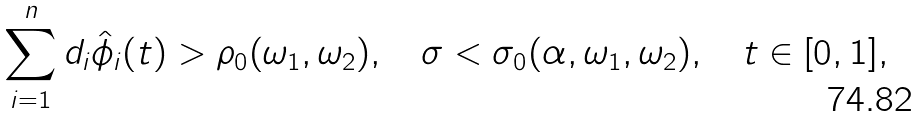Convert formula to latex. <formula><loc_0><loc_0><loc_500><loc_500>\sum _ { i = 1 } ^ { n } d _ { i } \hat { \phi } _ { i } ( t ) & > \rho _ { 0 } ( \omega _ { 1 } , \omega _ { 2 } ) , \quad \sigma < \sigma _ { 0 } ( \alpha , \omega _ { 1 } , \omega _ { 2 } ) , \quad t \in [ 0 , 1 ] ,</formula> 